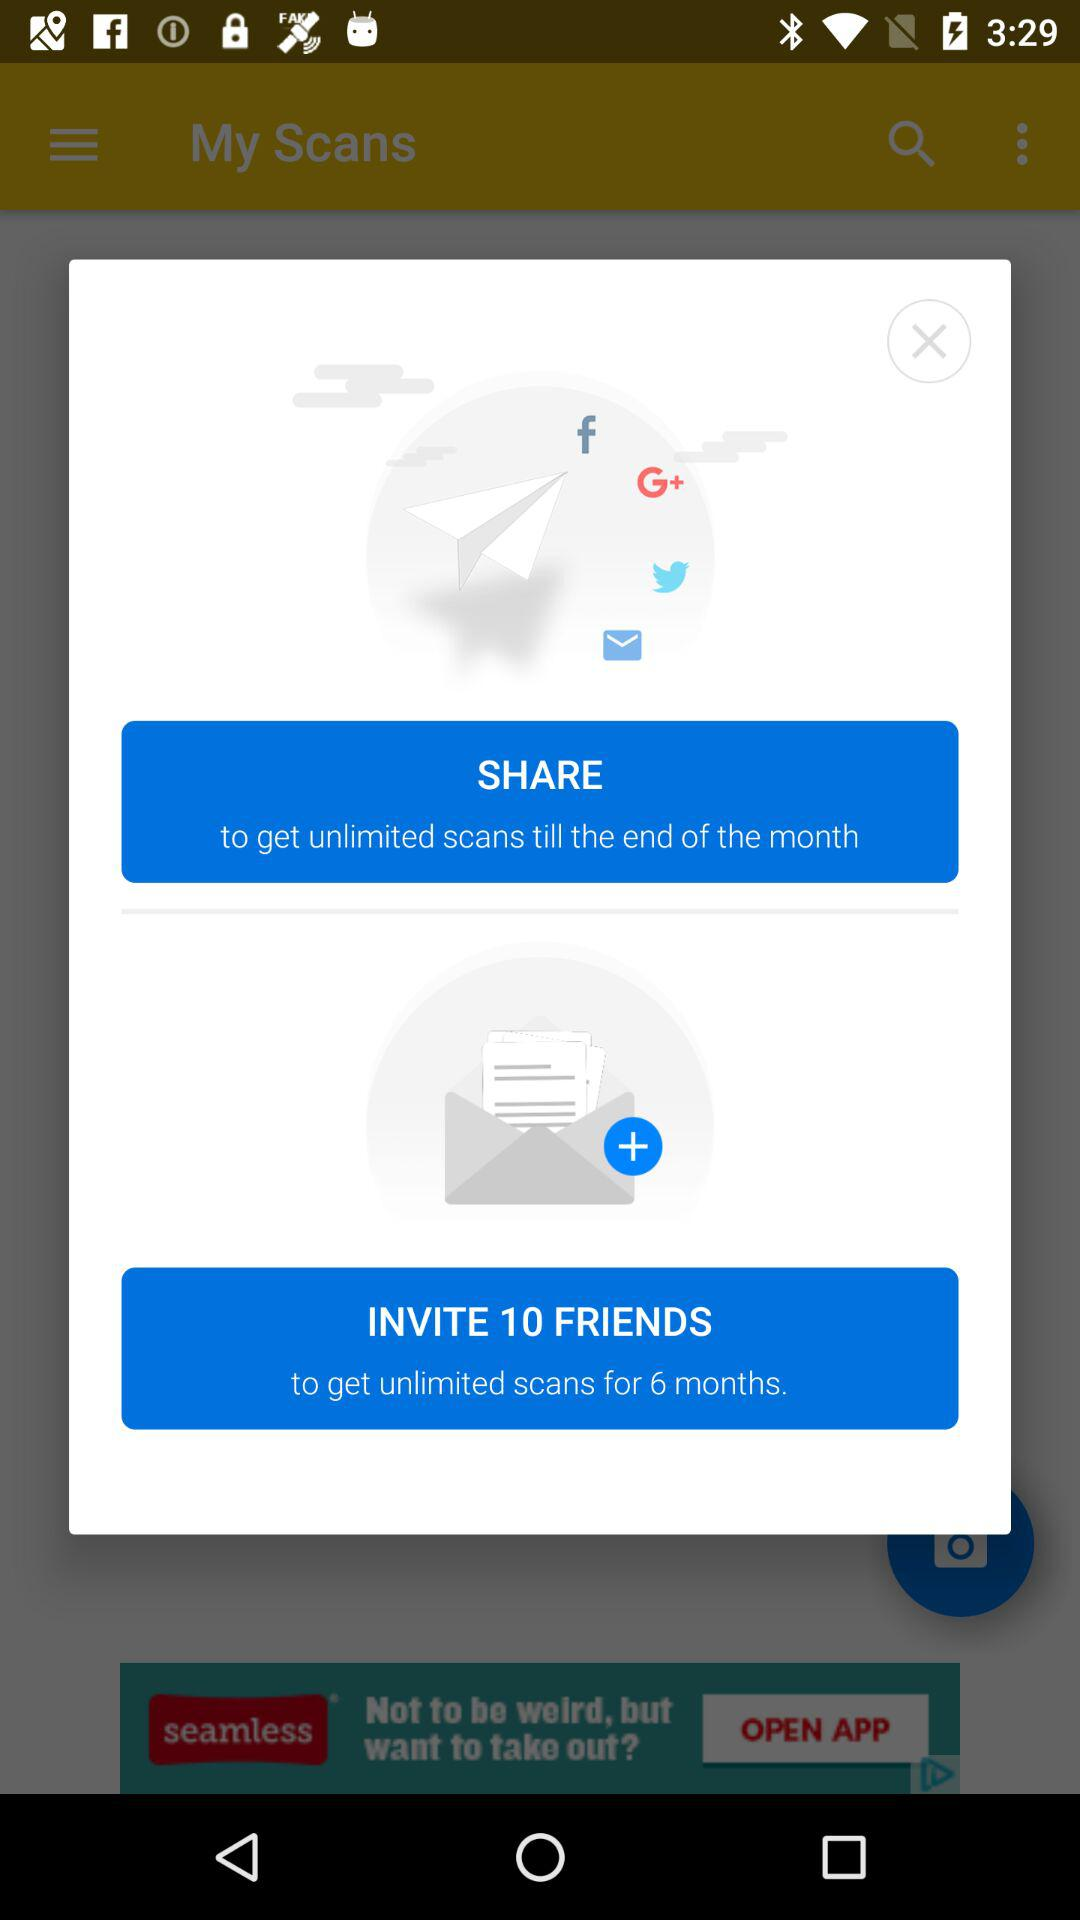How long is the duration for unlimited scans after sending invites? The duration for unlimited scans is 6 months. 